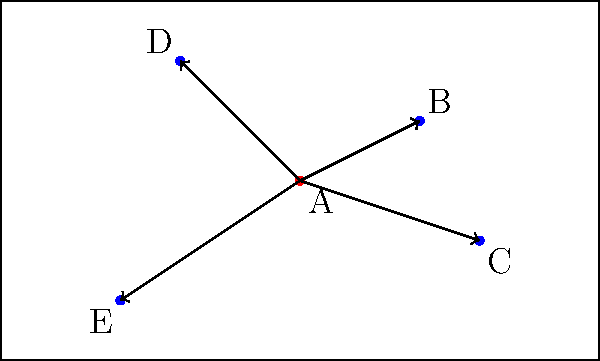Based on the soccer player position chart shown, which passing route from player A (in red) is likely to be the most optimal in terms of creating a scoring opportunity? To determine the most optimal passing route for creating a scoring opportunity, we need to consider several factors:

1. Field position: Passes that advance the ball towards the opponent's goal are generally more advantageous.

2. Defensive pressure: Players with more space around them are in better positions to receive passes and create opportunities.

3. Attacking options: Players who can quickly pass or shoot after receiving the ball are more likely to create scoring chances.

4. Angle of attack: Passes that allow for a direct path to the goal are more likely to lead to scoring opportunities.

Analyzing the options:

A to B: This pass moves the ball forward and to the right, potentially opening up the field. Player B seems to have space around them.

A to C: This pass also moves the ball forward but at a wider angle. Player C might have a good shooting angle.

A to D: This pass moves the ball backwards, which is generally less advantageous for creating immediate scoring opportunities.

A to E: This pass moves the ball backwards and to the left, potentially losing field position.

Considering these factors, the pass from A to B appears to be the most optimal. It advances the ball, keeps it central, and gives player B options to either shoot or make another pass forward.
Answer: A to B 